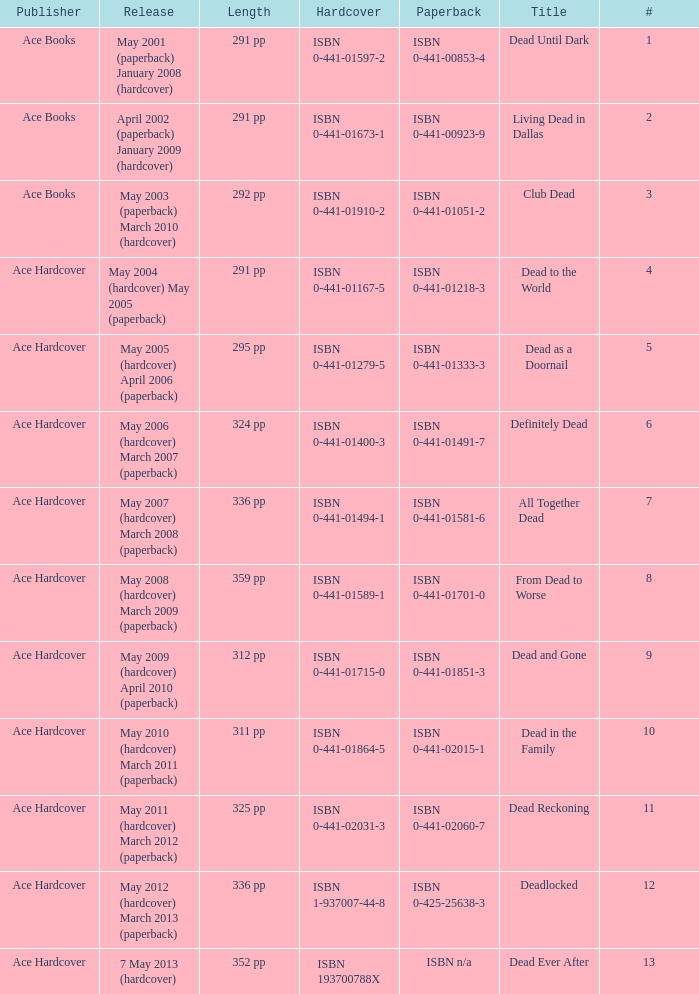Who pubilshed isbn 1-937007-44-8? Ace Hardcover. 